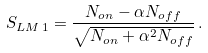Convert formula to latex. <formula><loc_0><loc_0><loc_500><loc_500>S _ { L M \, 1 } = \frac { N _ { o n } - \alpha N _ { o f f } } { \sqrt { N _ { o n } + \alpha ^ { 2 } N _ { o f f } } } \, .</formula> 